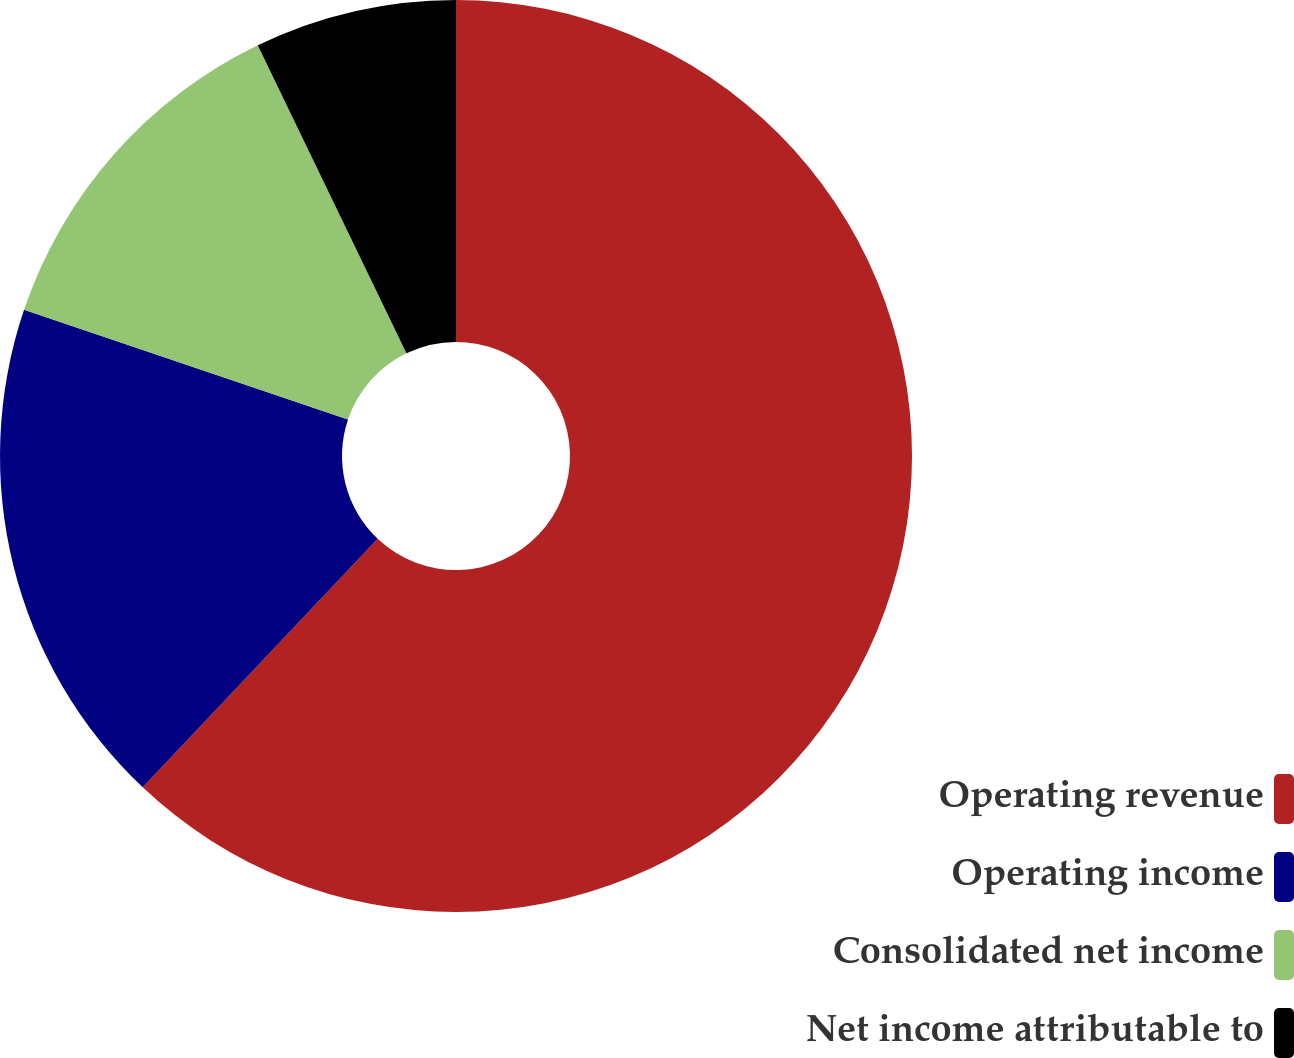Convert chart to OTSL. <chart><loc_0><loc_0><loc_500><loc_500><pie_chart><fcel>Operating revenue<fcel>Operating income<fcel>Consolidated net income<fcel>Net income attributable to<nl><fcel>62.06%<fcel>18.14%<fcel>12.65%<fcel>7.16%<nl></chart> 